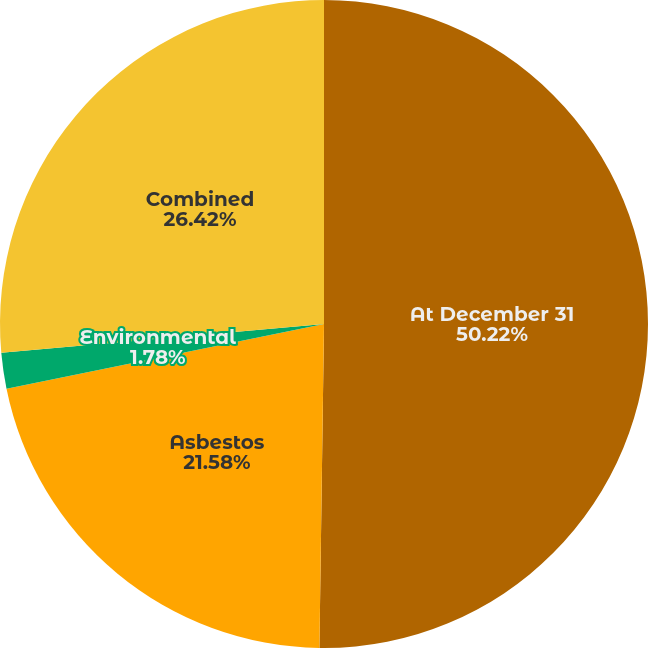Convert chart. <chart><loc_0><loc_0><loc_500><loc_500><pie_chart><fcel>At December 31<fcel>Asbestos<fcel>Environmental<fcel>Combined<nl><fcel>50.23%<fcel>21.58%<fcel>1.78%<fcel>26.42%<nl></chart> 